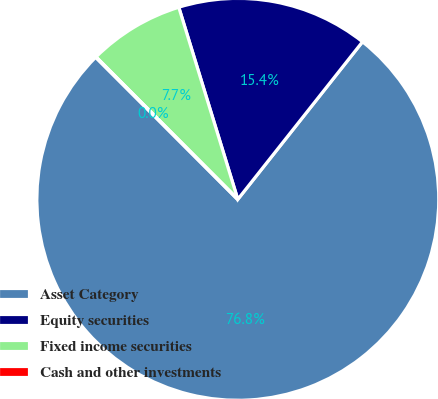<chart> <loc_0><loc_0><loc_500><loc_500><pie_chart><fcel>Asset Category<fcel>Equity securities<fcel>Fixed income securities<fcel>Cash and other investments<nl><fcel>76.84%<fcel>15.4%<fcel>7.72%<fcel>0.04%<nl></chart> 